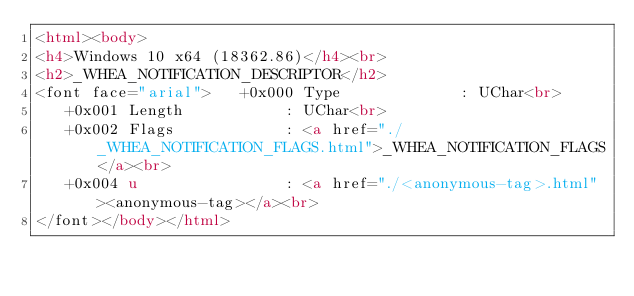Convert code to text. <code><loc_0><loc_0><loc_500><loc_500><_HTML_><html><body>
<h4>Windows 10 x64 (18362.86)</h4><br>
<h2>_WHEA_NOTIFICATION_DESCRIPTOR</h2>
<font face="arial">   +0x000 Type             : UChar<br>
   +0x001 Length           : UChar<br>
   +0x002 Flags            : <a href="./_WHEA_NOTIFICATION_FLAGS.html">_WHEA_NOTIFICATION_FLAGS</a><br>
   +0x004 u                : <a href="./<anonymous-tag>.html"><anonymous-tag></a><br>
</font></body></html></code> 